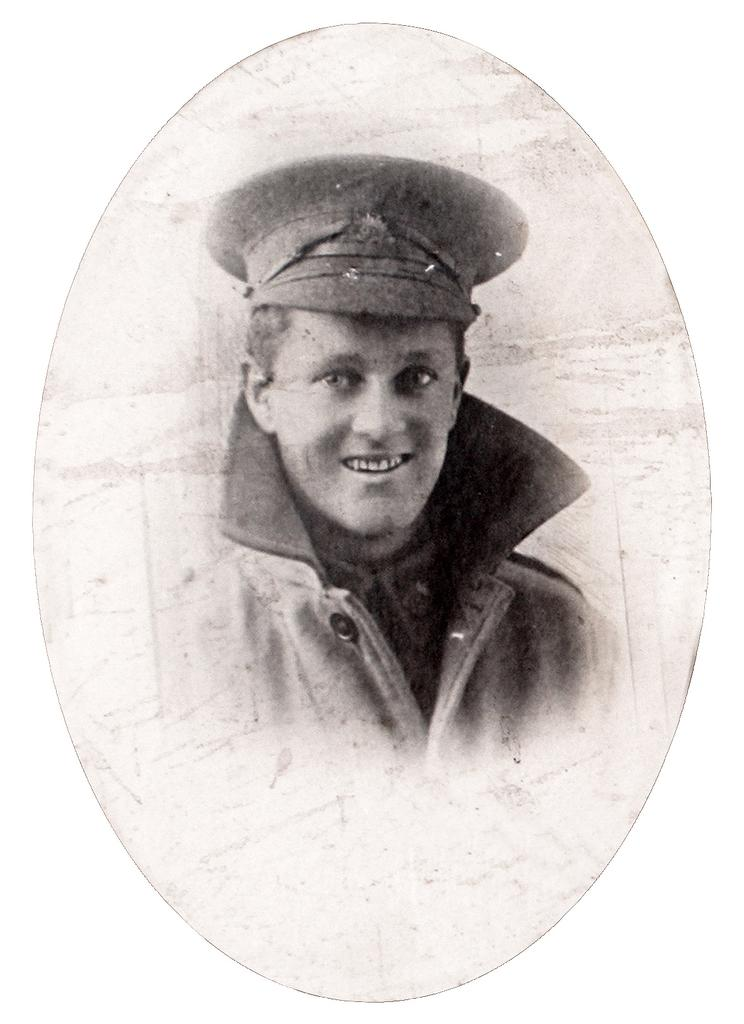What is the color scheme of the image? The image is black and white. Can you describe the person in the image? There is a person in the image. What expression does the person have on their face? The person is wearing a smile on his face. Can you tell me how many donkeys are present in the image? There are no donkeys present in the image; it features a person with a smile. What type of hand gesture is the person making in the image? The provided facts do not mention any hand gestures made by the person in the image. 